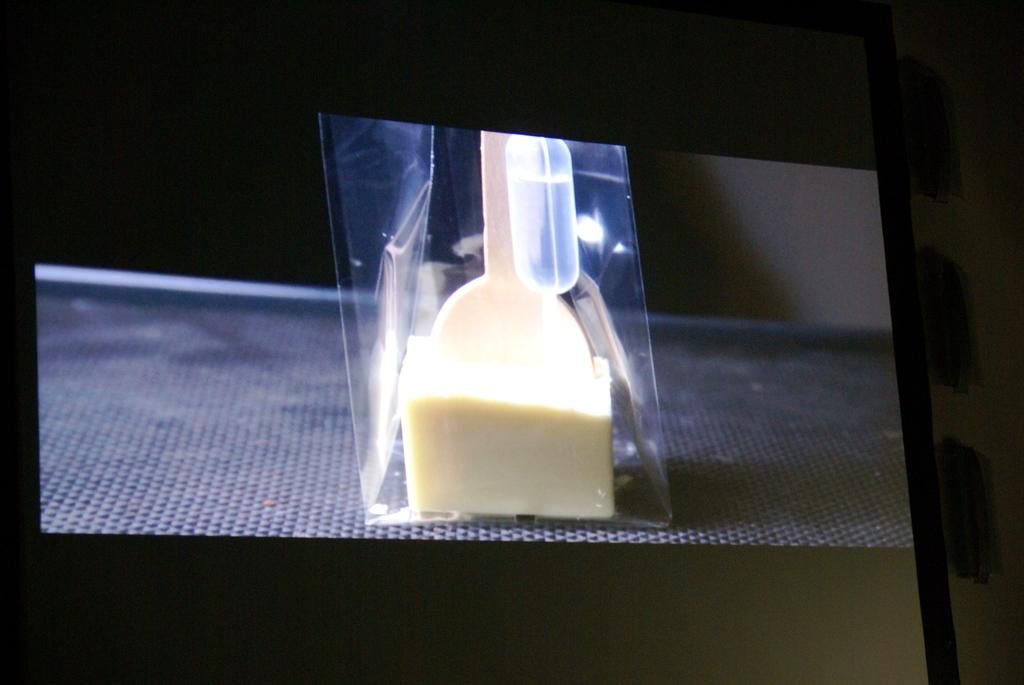What is being displayed on the screen in the image? There is an object displayed on the screen in the image. What type of fuel is being used by the object on the screen? There is no information about fuel in the image, as it only shows an object displayed on the screen. 